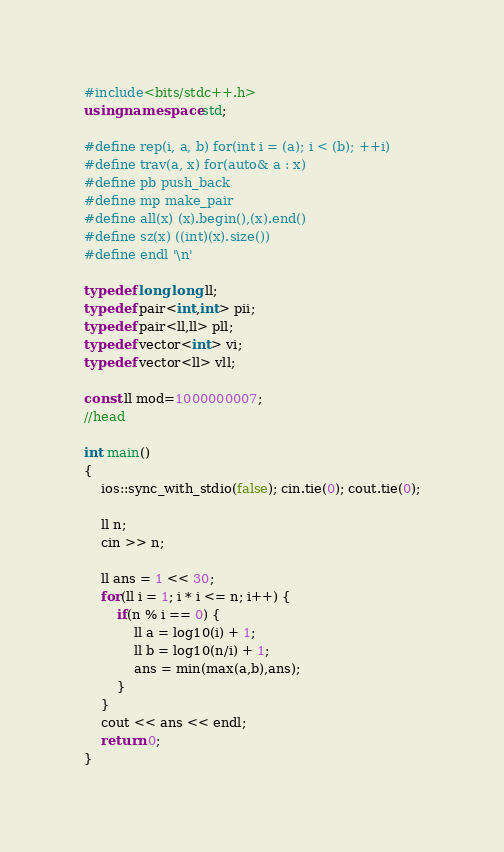Convert code to text. <code><loc_0><loc_0><loc_500><loc_500><_C++_>#include<bits/stdc++.h>
using namespace std;

#define rep(i, a, b) for(int i = (a); i < (b); ++i)
#define trav(a, x) for(auto& a : x)
#define pb push_back
#define mp make_pair
#define all(x) (x).begin(),(x).end()
#define sz(x) ((int)(x).size())
#define endl '\n'

typedef long long ll;
typedef pair<int,int> pii;
typedef pair<ll,ll> pll;
typedef vector<int> vi;
typedef vector<ll> vll;

const ll mod=1000000007;
//head

int main()
{
    ios::sync_with_stdio(false); cin.tie(0); cout.tie(0);

    ll n;
    cin >> n;

    ll ans = 1 << 30;
    for(ll i = 1; i * i <= n; i++) {
        if(n % i == 0) {
            ll a = log10(i) + 1;
            ll b = log10(n/i) + 1;
            ans = min(max(a,b),ans);
        }
    }
    cout << ans << endl;
    return 0;
}
</code> 